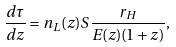Convert formula to latex. <formula><loc_0><loc_0><loc_500><loc_500>\frac { d \tau } { d z } = n _ { L } ( z ) S \frac { r _ { H } } { E ( z ) ( 1 + z ) } ,</formula> 